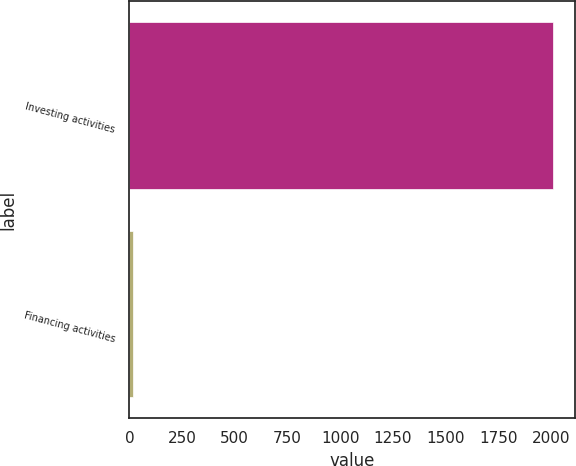<chart> <loc_0><loc_0><loc_500><loc_500><bar_chart><fcel>Investing activities<fcel>Financing activities<nl><fcel>2012<fcel>16<nl></chart> 